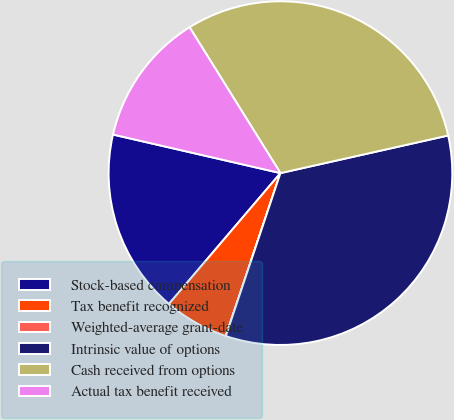Convert chart to OTSL. <chart><loc_0><loc_0><loc_500><loc_500><pie_chart><fcel>Stock-based compensation<fcel>Tax benefit recognized<fcel>Weighted-average grant-date<fcel>Intrinsic value of options<fcel>Cash received from options<fcel>Actual tax benefit received<nl><fcel>17.37%<fcel>6.08%<fcel>0.01%<fcel>33.66%<fcel>30.36%<fcel>12.53%<nl></chart> 